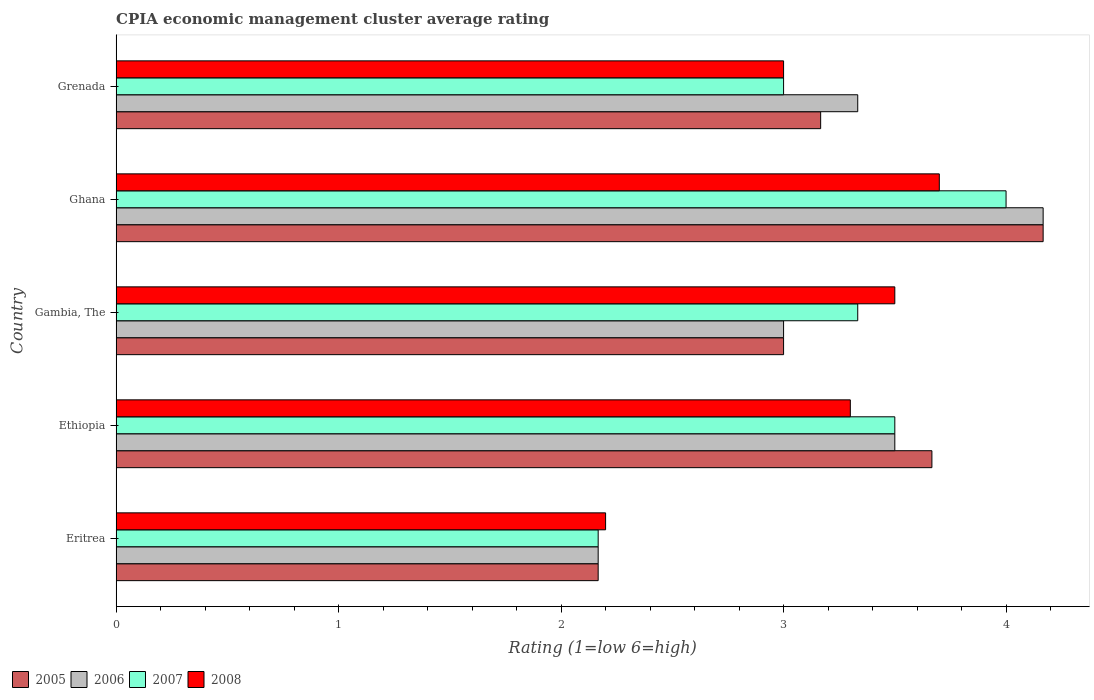How many different coloured bars are there?
Your answer should be very brief. 4. Are the number of bars per tick equal to the number of legend labels?
Keep it short and to the point. Yes. Are the number of bars on each tick of the Y-axis equal?
Ensure brevity in your answer.  Yes. What is the label of the 4th group of bars from the top?
Make the answer very short. Ethiopia. What is the CPIA rating in 2006 in Gambia, The?
Give a very brief answer. 3. Across all countries, what is the minimum CPIA rating in 2008?
Provide a short and direct response. 2.2. In which country was the CPIA rating in 2008 maximum?
Your answer should be compact. Ghana. In which country was the CPIA rating in 2008 minimum?
Your answer should be compact. Eritrea. What is the difference between the CPIA rating in 2008 in Eritrea and that in Ethiopia?
Keep it short and to the point. -1.1. What is the difference between the CPIA rating in 2007 in Gambia, The and the CPIA rating in 2006 in Ethiopia?
Ensure brevity in your answer.  -0.17. What is the average CPIA rating in 2005 per country?
Offer a terse response. 3.23. In how many countries, is the CPIA rating in 2007 greater than 4 ?
Provide a short and direct response. 0. What is the ratio of the CPIA rating in 2006 in Ethiopia to that in Grenada?
Make the answer very short. 1.05. What is the difference between the highest and the second highest CPIA rating in 2006?
Ensure brevity in your answer.  0.67. What is the difference between the highest and the lowest CPIA rating in 2006?
Your answer should be very brief. 2. Is it the case that in every country, the sum of the CPIA rating in 2005 and CPIA rating in 2007 is greater than the sum of CPIA rating in 2008 and CPIA rating in 2006?
Your answer should be compact. No. Is it the case that in every country, the sum of the CPIA rating in 2006 and CPIA rating in 2005 is greater than the CPIA rating in 2007?
Offer a terse response. Yes. How many countries are there in the graph?
Offer a terse response. 5. What is the difference between two consecutive major ticks on the X-axis?
Your answer should be compact. 1. Does the graph contain any zero values?
Provide a succinct answer. No. Where does the legend appear in the graph?
Make the answer very short. Bottom left. How many legend labels are there?
Offer a terse response. 4. What is the title of the graph?
Offer a very short reply. CPIA economic management cluster average rating. What is the Rating (1=low 6=high) of 2005 in Eritrea?
Ensure brevity in your answer.  2.17. What is the Rating (1=low 6=high) in 2006 in Eritrea?
Provide a succinct answer. 2.17. What is the Rating (1=low 6=high) in 2007 in Eritrea?
Your answer should be very brief. 2.17. What is the Rating (1=low 6=high) in 2005 in Ethiopia?
Offer a terse response. 3.67. What is the Rating (1=low 6=high) in 2006 in Ethiopia?
Make the answer very short. 3.5. What is the Rating (1=low 6=high) in 2007 in Ethiopia?
Offer a very short reply. 3.5. What is the Rating (1=low 6=high) in 2008 in Ethiopia?
Your response must be concise. 3.3. What is the Rating (1=low 6=high) of 2007 in Gambia, The?
Your answer should be very brief. 3.33. What is the Rating (1=low 6=high) in 2005 in Ghana?
Provide a succinct answer. 4.17. What is the Rating (1=low 6=high) of 2006 in Ghana?
Your response must be concise. 4.17. What is the Rating (1=low 6=high) in 2007 in Ghana?
Your response must be concise. 4. What is the Rating (1=low 6=high) of 2008 in Ghana?
Keep it short and to the point. 3.7. What is the Rating (1=low 6=high) of 2005 in Grenada?
Make the answer very short. 3.17. What is the Rating (1=low 6=high) in 2006 in Grenada?
Provide a short and direct response. 3.33. What is the Rating (1=low 6=high) in 2007 in Grenada?
Provide a succinct answer. 3. Across all countries, what is the maximum Rating (1=low 6=high) in 2005?
Your response must be concise. 4.17. Across all countries, what is the maximum Rating (1=low 6=high) of 2006?
Give a very brief answer. 4.17. Across all countries, what is the maximum Rating (1=low 6=high) of 2008?
Keep it short and to the point. 3.7. Across all countries, what is the minimum Rating (1=low 6=high) of 2005?
Your answer should be very brief. 2.17. Across all countries, what is the minimum Rating (1=low 6=high) of 2006?
Offer a very short reply. 2.17. Across all countries, what is the minimum Rating (1=low 6=high) in 2007?
Provide a short and direct response. 2.17. What is the total Rating (1=low 6=high) in 2005 in the graph?
Provide a succinct answer. 16.17. What is the total Rating (1=low 6=high) of 2006 in the graph?
Keep it short and to the point. 16.17. What is the difference between the Rating (1=low 6=high) of 2005 in Eritrea and that in Ethiopia?
Provide a short and direct response. -1.5. What is the difference between the Rating (1=low 6=high) of 2006 in Eritrea and that in Ethiopia?
Provide a succinct answer. -1.33. What is the difference between the Rating (1=low 6=high) of 2007 in Eritrea and that in Ethiopia?
Provide a succinct answer. -1.33. What is the difference between the Rating (1=low 6=high) in 2008 in Eritrea and that in Ethiopia?
Make the answer very short. -1.1. What is the difference between the Rating (1=low 6=high) of 2006 in Eritrea and that in Gambia, The?
Provide a short and direct response. -0.83. What is the difference between the Rating (1=low 6=high) of 2007 in Eritrea and that in Gambia, The?
Offer a very short reply. -1.17. What is the difference between the Rating (1=low 6=high) of 2005 in Eritrea and that in Ghana?
Your answer should be compact. -2. What is the difference between the Rating (1=low 6=high) of 2006 in Eritrea and that in Ghana?
Provide a short and direct response. -2. What is the difference between the Rating (1=low 6=high) of 2007 in Eritrea and that in Ghana?
Offer a terse response. -1.83. What is the difference between the Rating (1=low 6=high) in 2008 in Eritrea and that in Ghana?
Offer a very short reply. -1.5. What is the difference between the Rating (1=low 6=high) in 2006 in Eritrea and that in Grenada?
Keep it short and to the point. -1.17. What is the difference between the Rating (1=low 6=high) in 2007 in Eritrea and that in Grenada?
Provide a short and direct response. -0.83. What is the difference between the Rating (1=low 6=high) of 2008 in Eritrea and that in Grenada?
Provide a short and direct response. -0.8. What is the difference between the Rating (1=low 6=high) in 2006 in Ethiopia and that in Gambia, The?
Make the answer very short. 0.5. What is the difference between the Rating (1=low 6=high) in 2007 in Ethiopia and that in Gambia, The?
Provide a short and direct response. 0.17. What is the difference between the Rating (1=low 6=high) of 2005 in Ethiopia and that in Ghana?
Provide a short and direct response. -0.5. What is the difference between the Rating (1=low 6=high) in 2006 in Ethiopia and that in Ghana?
Your response must be concise. -0.67. What is the difference between the Rating (1=low 6=high) of 2007 in Ethiopia and that in Ghana?
Offer a very short reply. -0.5. What is the difference between the Rating (1=low 6=high) of 2008 in Ethiopia and that in Ghana?
Ensure brevity in your answer.  -0.4. What is the difference between the Rating (1=low 6=high) in 2007 in Ethiopia and that in Grenada?
Provide a succinct answer. 0.5. What is the difference between the Rating (1=low 6=high) of 2005 in Gambia, The and that in Ghana?
Offer a terse response. -1.17. What is the difference between the Rating (1=low 6=high) of 2006 in Gambia, The and that in Ghana?
Ensure brevity in your answer.  -1.17. What is the difference between the Rating (1=low 6=high) of 2005 in Gambia, The and that in Grenada?
Provide a succinct answer. -0.17. What is the difference between the Rating (1=low 6=high) of 2007 in Gambia, The and that in Grenada?
Give a very brief answer. 0.33. What is the difference between the Rating (1=low 6=high) of 2008 in Gambia, The and that in Grenada?
Your answer should be compact. 0.5. What is the difference between the Rating (1=low 6=high) in 2005 in Eritrea and the Rating (1=low 6=high) in 2006 in Ethiopia?
Provide a succinct answer. -1.33. What is the difference between the Rating (1=low 6=high) of 2005 in Eritrea and the Rating (1=low 6=high) of 2007 in Ethiopia?
Make the answer very short. -1.33. What is the difference between the Rating (1=low 6=high) in 2005 in Eritrea and the Rating (1=low 6=high) in 2008 in Ethiopia?
Keep it short and to the point. -1.13. What is the difference between the Rating (1=low 6=high) of 2006 in Eritrea and the Rating (1=low 6=high) of 2007 in Ethiopia?
Offer a terse response. -1.33. What is the difference between the Rating (1=low 6=high) of 2006 in Eritrea and the Rating (1=low 6=high) of 2008 in Ethiopia?
Provide a short and direct response. -1.13. What is the difference between the Rating (1=low 6=high) of 2007 in Eritrea and the Rating (1=low 6=high) of 2008 in Ethiopia?
Offer a very short reply. -1.13. What is the difference between the Rating (1=low 6=high) in 2005 in Eritrea and the Rating (1=low 6=high) in 2006 in Gambia, The?
Make the answer very short. -0.83. What is the difference between the Rating (1=low 6=high) in 2005 in Eritrea and the Rating (1=low 6=high) in 2007 in Gambia, The?
Your response must be concise. -1.17. What is the difference between the Rating (1=low 6=high) in 2005 in Eritrea and the Rating (1=low 6=high) in 2008 in Gambia, The?
Offer a very short reply. -1.33. What is the difference between the Rating (1=low 6=high) in 2006 in Eritrea and the Rating (1=low 6=high) in 2007 in Gambia, The?
Offer a very short reply. -1.17. What is the difference between the Rating (1=low 6=high) of 2006 in Eritrea and the Rating (1=low 6=high) of 2008 in Gambia, The?
Provide a succinct answer. -1.33. What is the difference between the Rating (1=low 6=high) of 2007 in Eritrea and the Rating (1=low 6=high) of 2008 in Gambia, The?
Provide a short and direct response. -1.33. What is the difference between the Rating (1=low 6=high) of 2005 in Eritrea and the Rating (1=low 6=high) of 2006 in Ghana?
Offer a terse response. -2. What is the difference between the Rating (1=low 6=high) in 2005 in Eritrea and the Rating (1=low 6=high) in 2007 in Ghana?
Offer a terse response. -1.83. What is the difference between the Rating (1=low 6=high) in 2005 in Eritrea and the Rating (1=low 6=high) in 2008 in Ghana?
Your response must be concise. -1.53. What is the difference between the Rating (1=low 6=high) in 2006 in Eritrea and the Rating (1=low 6=high) in 2007 in Ghana?
Keep it short and to the point. -1.83. What is the difference between the Rating (1=low 6=high) in 2006 in Eritrea and the Rating (1=low 6=high) in 2008 in Ghana?
Your response must be concise. -1.53. What is the difference between the Rating (1=low 6=high) of 2007 in Eritrea and the Rating (1=low 6=high) of 2008 in Ghana?
Your answer should be very brief. -1.53. What is the difference between the Rating (1=low 6=high) of 2005 in Eritrea and the Rating (1=low 6=high) of 2006 in Grenada?
Offer a terse response. -1.17. What is the difference between the Rating (1=low 6=high) in 2005 in Eritrea and the Rating (1=low 6=high) in 2007 in Grenada?
Your response must be concise. -0.83. What is the difference between the Rating (1=low 6=high) in 2005 in Eritrea and the Rating (1=low 6=high) in 2008 in Grenada?
Give a very brief answer. -0.83. What is the difference between the Rating (1=low 6=high) of 2006 in Eritrea and the Rating (1=low 6=high) of 2007 in Grenada?
Offer a terse response. -0.83. What is the difference between the Rating (1=low 6=high) in 2005 in Ethiopia and the Rating (1=low 6=high) in 2006 in Gambia, The?
Ensure brevity in your answer.  0.67. What is the difference between the Rating (1=low 6=high) in 2005 in Ethiopia and the Rating (1=low 6=high) in 2007 in Gambia, The?
Your answer should be very brief. 0.33. What is the difference between the Rating (1=low 6=high) of 2006 in Ethiopia and the Rating (1=low 6=high) of 2007 in Gambia, The?
Provide a short and direct response. 0.17. What is the difference between the Rating (1=low 6=high) in 2006 in Ethiopia and the Rating (1=low 6=high) in 2008 in Gambia, The?
Your answer should be compact. 0. What is the difference between the Rating (1=low 6=high) in 2007 in Ethiopia and the Rating (1=low 6=high) in 2008 in Gambia, The?
Offer a very short reply. 0. What is the difference between the Rating (1=low 6=high) in 2005 in Ethiopia and the Rating (1=low 6=high) in 2006 in Ghana?
Make the answer very short. -0.5. What is the difference between the Rating (1=low 6=high) in 2005 in Ethiopia and the Rating (1=low 6=high) in 2007 in Ghana?
Make the answer very short. -0.33. What is the difference between the Rating (1=low 6=high) in 2005 in Ethiopia and the Rating (1=low 6=high) in 2008 in Ghana?
Offer a very short reply. -0.03. What is the difference between the Rating (1=low 6=high) of 2006 in Ethiopia and the Rating (1=low 6=high) of 2007 in Ghana?
Provide a succinct answer. -0.5. What is the difference between the Rating (1=low 6=high) of 2005 in Ethiopia and the Rating (1=low 6=high) of 2007 in Grenada?
Keep it short and to the point. 0.67. What is the difference between the Rating (1=low 6=high) in 2005 in Ethiopia and the Rating (1=low 6=high) in 2008 in Grenada?
Provide a succinct answer. 0.67. What is the difference between the Rating (1=low 6=high) of 2006 in Ethiopia and the Rating (1=low 6=high) of 2007 in Grenada?
Offer a very short reply. 0.5. What is the difference between the Rating (1=low 6=high) of 2007 in Ethiopia and the Rating (1=low 6=high) of 2008 in Grenada?
Provide a short and direct response. 0.5. What is the difference between the Rating (1=low 6=high) in 2005 in Gambia, The and the Rating (1=low 6=high) in 2006 in Ghana?
Keep it short and to the point. -1.17. What is the difference between the Rating (1=low 6=high) in 2005 in Gambia, The and the Rating (1=low 6=high) in 2007 in Ghana?
Provide a succinct answer. -1. What is the difference between the Rating (1=low 6=high) in 2005 in Gambia, The and the Rating (1=low 6=high) in 2008 in Ghana?
Ensure brevity in your answer.  -0.7. What is the difference between the Rating (1=low 6=high) in 2007 in Gambia, The and the Rating (1=low 6=high) in 2008 in Ghana?
Offer a terse response. -0.37. What is the difference between the Rating (1=low 6=high) of 2005 in Gambia, The and the Rating (1=low 6=high) of 2007 in Grenada?
Your response must be concise. 0. What is the difference between the Rating (1=low 6=high) in 2005 in Gambia, The and the Rating (1=low 6=high) in 2008 in Grenada?
Your answer should be compact. 0. What is the difference between the Rating (1=low 6=high) in 2006 in Gambia, The and the Rating (1=low 6=high) in 2008 in Grenada?
Keep it short and to the point. 0. What is the difference between the Rating (1=low 6=high) in 2007 in Gambia, The and the Rating (1=low 6=high) in 2008 in Grenada?
Ensure brevity in your answer.  0.33. What is the difference between the Rating (1=low 6=high) of 2005 in Ghana and the Rating (1=low 6=high) of 2006 in Grenada?
Keep it short and to the point. 0.83. What is the difference between the Rating (1=low 6=high) of 2005 in Ghana and the Rating (1=low 6=high) of 2007 in Grenada?
Offer a terse response. 1.17. What is the difference between the Rating (1=low 6=high) in 2006 in Ghana and the Rating (1=low 6=high) in 2007 in Grenada?
Give a very brief answer. 1.17. What is the average Rating (1=low 6=high) in 2005 per country?
Offer a very short reply. 3.23. What is the average Rating (1=low 6=high) in 2006 per country?
Provide a succinct answer. 3.23. What is the average Rating (1=low 6=high) of 2007 per country?
Offer a very short reply. 3.2. What is the average Rating (1=low 6=high) of 2008 per country?
Provide a short and direct response. 3.14. What is the difference between the Rating (1=low 6=high) in 2005 and Rating (1=low 6=high) in 2006 in Eritrea?
Give a very brief answer. 0. What is the difference between the Rating (1=low 6=high) of 2005 and Rating (1=low 6=high) of 2007 in Eritrea?
Offer a very short reply. 0. What is the difference between the Rating (1=low 6=high) in 2005 and Rating (1=low 6=high) in 2008 in Eritrea?
Ensure brevity in your answer.  -0.03. What is the difference between the Rating (1=low 6=high) in 2006 and Rating (1=low 6=high) in 2008 in Eritrea?
Give a very brief answer. -0.03. What is the difference between the Rating (1=low 6=high) in 2007 and Rating (1=low 6=high) in 2008 in Eritrea?
Make the answer very short. -0.03. What is the difference between the Rating (1=low 6=high) of 2005 and Rating (1=low 6=high) of 2008 in Ethiopia?
Your response must be concise. 0.37. What is the difference between the Rating (1=low 6=high) in 2006 and Rating (1=low 6=high) in 2007 in Ethiopia?
Your response must be concise. 0. What is the difference between the Rating (1=low 6=high) in 2005 and Rating (1=low 6=high) in 2006 in Gambia, The?
Your answer should be very brief. 0. What is the difference between the Rating (1=low 6=high) in 2005 and Rating (1=low 6=high) in 2007 in Gambia, The?
Offer a terse response. -0.33. What is the difference between the Rating (1=low 6=high) in 2007 and Rating (1=low 6=high) in 2008 in Gambia, The?
Provide a short and direct response. -0.17. What is the difference between the Rating (1=low 6=high) in 2005 and Rating (1=low 6=high) in 2007 in Ghana?
Offer a very short reply. 0.17. What is the difference between the Rating (1=low 6=high) of 2005 and Rating (1=low 6=high) of 2008 in Ghana?
Ensure brevity in your answer.  0.47. What is the difference between the Rating (1=low 6=high) of 2006 and Rating (1=low 6=high) of 2007 in Ghana?
Offer a terse response. 0.17. What is the difference between the Rating (1=low 6=high) in 2006 and Rating (1=low 6=high) in 2008 in Ghana?
Provide a short and direct response. 0.47. What is the difference between the Rating (1=low 6=high) in 2005 and Rating (1=low 6=high) in 2008 in Grenada?
Ensure brevity in your answer.  0.17. What is the difference between the Rating (1=low 6=high) of 2006 and Rating (1=low 6=high) of 2007 in Grenada?
Provide a short and direct response. 0.33. What is the difference between the Rating (1=low 6=high) of 2006 and Rating (1=low 6=high) of 2008 in Grenada?
Keep it short and to the point. 0.33. What is the ratio of the Rating (1=low 6=high) in 2005 in Eritrea to that in Ethiopia?
Offer a terse response. 0.59. What is the ratio of the Rating (1=low 6=high) in 2006 in Eritrea to that in Ethiopia?
Your answer should be compact. 0.62. What is the ratio of the Rating (1=low 6=high) of 2007 in Eritrea to that in Ethiopia?
Ensure brevity in your answer.  0.62. What is the ratio of the Rating (1=low 6=high) of 2008 in Eritrea to that in Ethiopia?
Offer a very short reply. 0.67. What is the ratio of the Rating (1=low 6=high) of 2005 in Eritrea to that in Gambia, The?
Offer a terse response. 0.72. What is the ratio of the Rating (1=low 6=high) in 2006 in Eritrea to that in Gambia, The?
Provide a succinct answer. 0.72. What is the ratio of the Rating (1=low 6=high) in 2007 in Eritrea to that in Gambia, The?
Your answer should be very brief. 0.65. What is the ratio of the Rating (1=low 6=high) in 2008 in Eritrea to that in Gambia, The?
Offer a very short reply. 0.63. What is the ratio of the Rating (1=low 6=high) in 2005 in Eritrea to that in Ghana?
Your answer should be very brief. 0.52. What is the ratio of the Rating (1=low 6=high) of 2006 in Eritrea to that in Ghana?
Make the answer very short. 0.52. What is the ratio of the Rating (1=low 6=high) in 2007 in Eritrea to that in Ghana?
Your answer should be compact. 0.54. What is the ratio of the Rating (1=low 6=high) of 2008 in Eritrea to that in Ghana?
Your answer should be very brief. 0.59. What is the ratio of the Rating (1=low 6=high) in 2005 in Eritrea to that in Grenada?
Provide a succinct answer. 0.68. What is the ratio of the Rating (1=low 6=high) in 2006 in Eritrea to that in Grenada?
Offer a very short reply. 0.65. What is the ratio of the Rating (1=low 6=high) of 2007 in Eritrea to that in Grenada?
Provide a short and direct response. 0.72. What is the ratio of the Rating (1=low 6=high) in 2008 in Eritrea to that in Grenada?
Make the answer very short. 0.73. What is the ratio of the Rating (1=low 6=high) of 2005 in Ethiopia to that in Gambia, The?
Make the answer very short. 1.22. What is the ratio of the Rating (1=low 6=high) of 2006 in Ethiopia to that in Gambia, The?
Your answer should be very brief. 1.17. What is the ratio of the Rating (1=low 6=high) in 2007 in Ethiopia to that in Gambia, The?
Make the answer very short. 1.05. What is the ratio of the Rating (1=low 6=high) of 2008 in Ethiopia to that in Gambia, The?
Keep it short and to the point. 0.94. What is the ratio of the Rating (1=low 6=high) in 2006 in Ethiopia to that in Ghana?
Your answer should be compact. 0.84. What is the ratio of the Rating (1=low 6=high) of 2007 in Ethiopia to that in Ghana?
Provide a short and direct response. 0.88. What is the ratio of the Rating (1=low 6=high) of 2008 in Ethiopia to that in Ghana?
Your response must be concise. 0.89. What is the ratio of the Rating (1=low 6=high) in 2005 in Ethiopia to that in Grenada?
Make the answer very short. 1.16. What is the ratio of the Rating (1=low 6=high) in 2008 in Ethiopia to that in Grenada?
Make the answer very short. 1.1. What is the ratio of the Rating (1=low 6=high) in 2005 in Gambia, The to that in Ghana?
Your answer should be very brief. 0.72. What is the ratio of the Rating (1=low 6=high) in 2006 in Gambia, The to that in Ghana?
Your answer should be very brief. 0.72. What is the ratio of the Rating (1=low 6=high) in 2007 in Gambia, The to that in Ghana?
Keep it short and to the point. 0.83. What is the ratio of the Rating (1=low 6=high) in 2008 in Gambia, The to that in Ghana?
Ensure brevity in your answer.  0.95. What is the ratio of the Rating (1=low 6=high) in 2005 in Gambia, The to that in Grenada?
Provide a short and direct response. 0.95. What is the ratio of the Rating (1=low 6=high) in 2008 in Gambia, The to that in Grenada?
Offer a very short reply. 1.17. What is the ratio of the Rating (1=low 6=high) in 2005 in Ghana to that in Grenada?
Your response must be concise. 1.32. What is the ratio of the Rating (1=low 6=high) in 2006 in Ghana to that in Grenada?
Provide a succinct answer. 1.25. What is the ratio of the Rating (1=low 6=high) of 2007 in Ghana to that in Grenada?
Your answer should be very brief. 1.33. What is the ratio of the Rating (1=low 6=high) of 2008 in Ghana to that in Grenada?
Your answer should be compact. 1.23. What is the difference between the highest and the second highest Rating (1=low 6=high) of 2005?
Provide a succinct answer. 0.5. What is the difference between the highest and the second highest Rating (1=low 6=high) in 2006?
Keep it short and to the point. 0.67. What is the difference between the highest and the second highest Rating (1=low 6=high) of 2007?
Provide a succinct answer. 0.5. What is the difference between the highest and the lowest Rating (1=low 6=high) in 2006?
Give a very brief answer. 2. What is the difference between the highest and the lowest Rating (1=low 6=high) of 2007?
Your answer should be very brief. 1.83. 